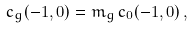Convert formula to latex. <formula><loc_0><loc_0><loc_500><loc_500>c _ { g } ( - 1 , 0 ) = m _ { g } \, c _ { 0 } ( - 1 , 0 ) \, ,</formula> 